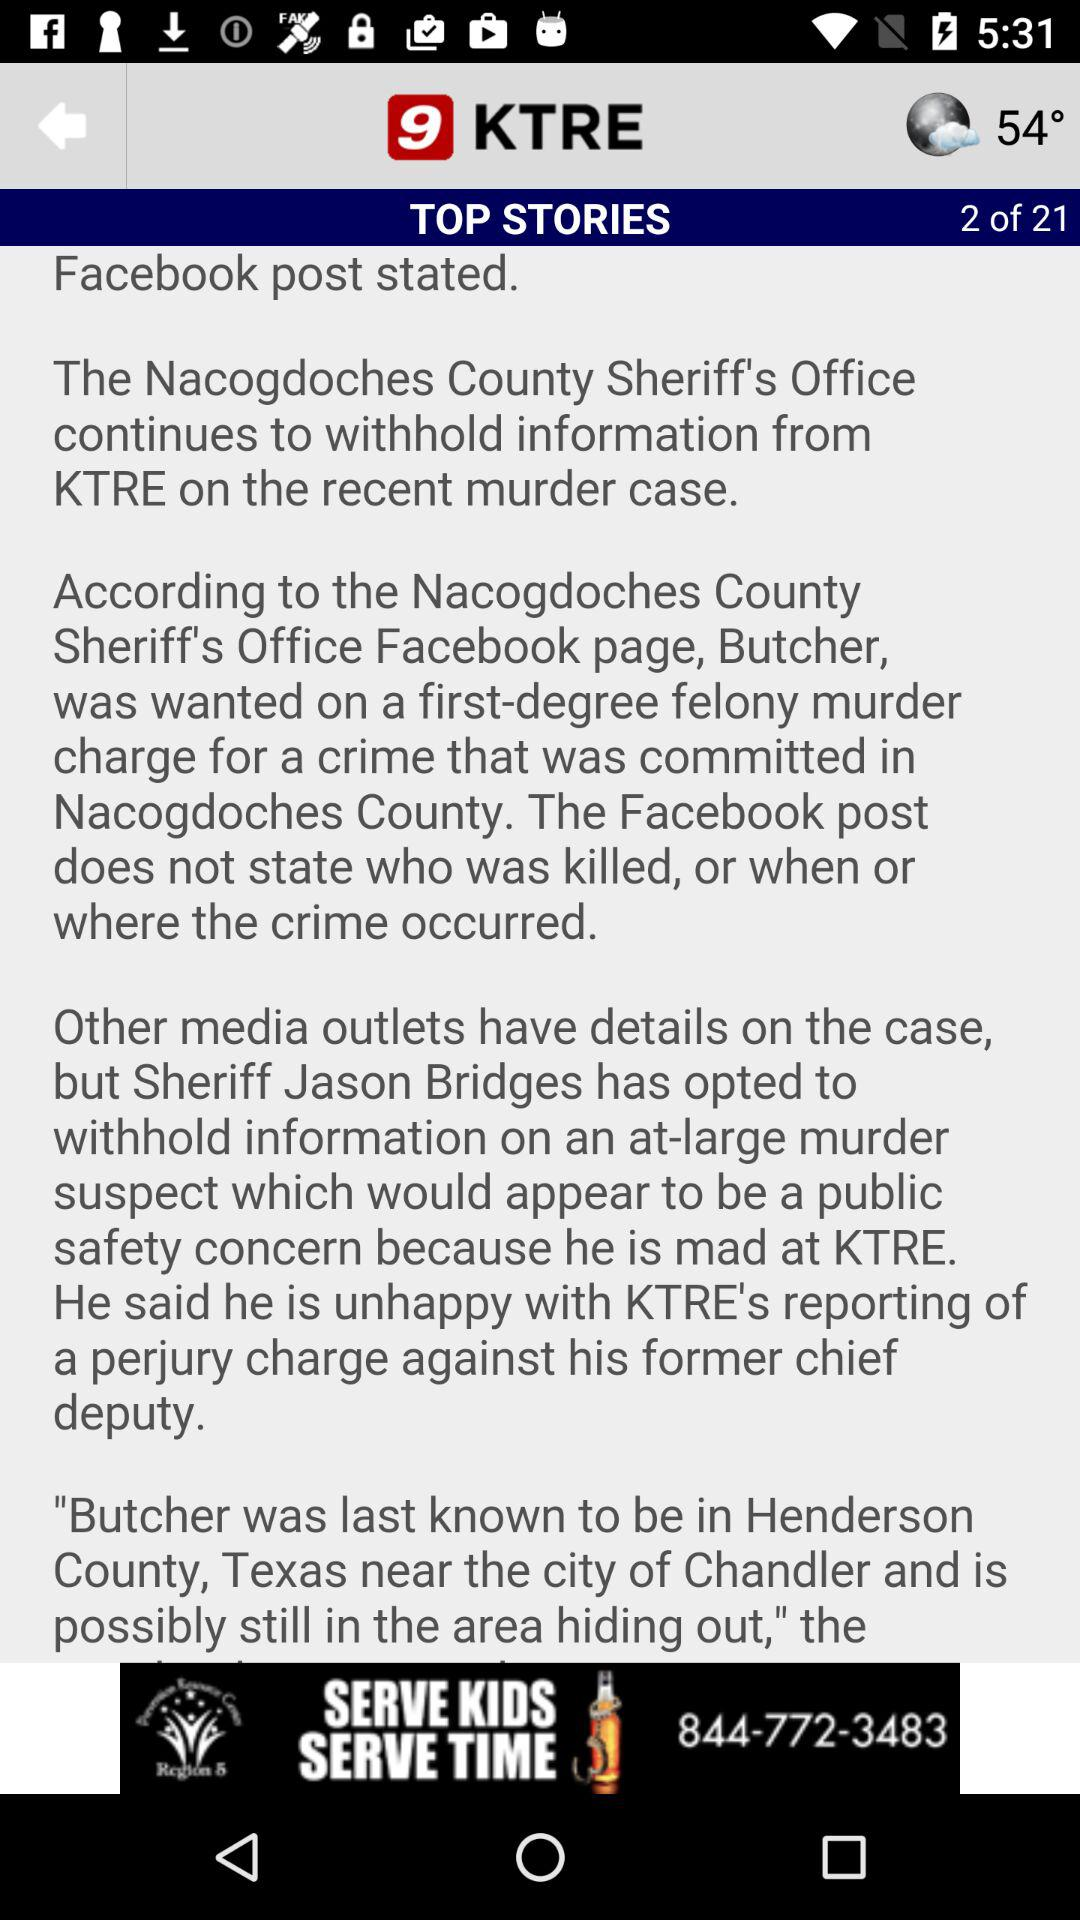Which page of top stories are we on? You are on page 2. 